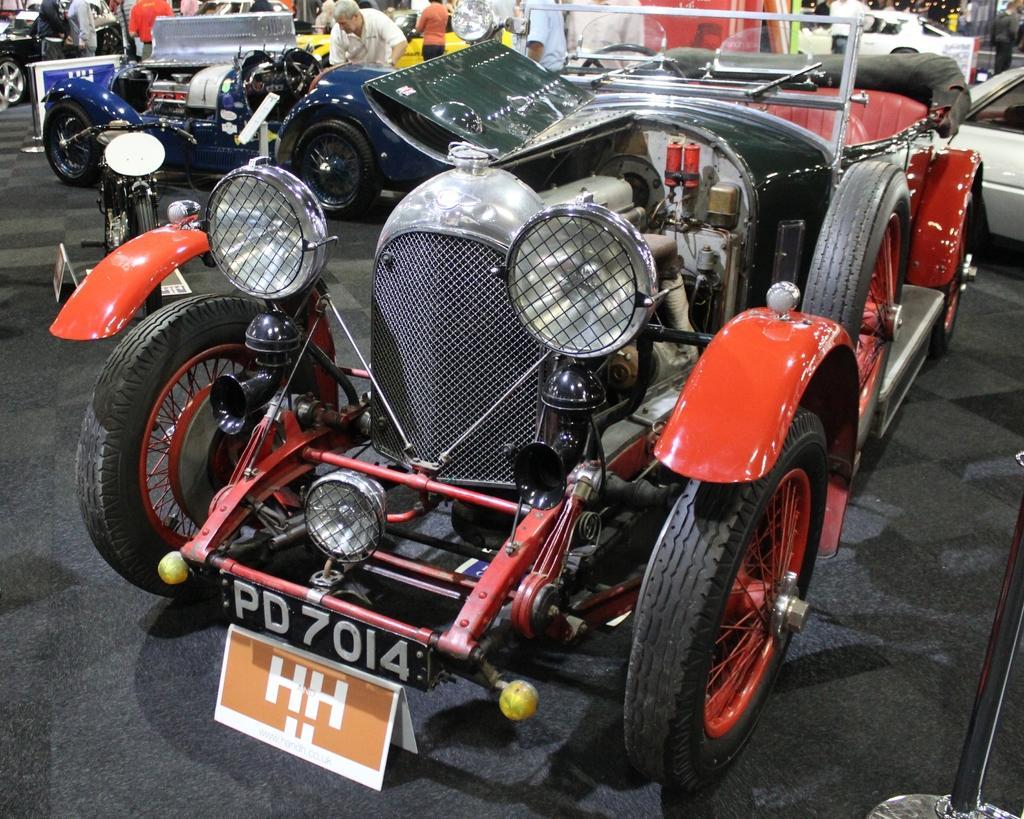Please provide a concise description of this image. In this image I can see vehicles and a group of people on the floor. This image is taken may be in a showroom. 